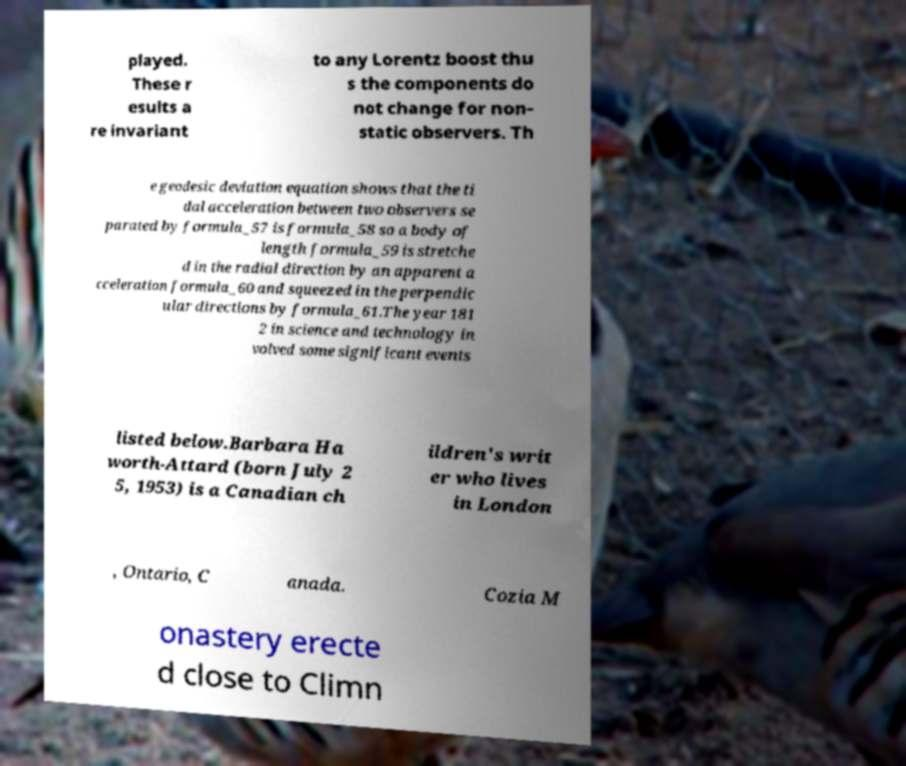Could you extract and type out the text from this image? played. These r esults a re invariant to any Lorentz boost thu s the components do not change for non- static observers. Th e geodesic deviation equation shows that the ti dal acceleration between two observers se parated by formula_57 is formula_58 so a body of length formula_59 is stretche d in the radial direction by an apparent a cceleration formula_60 and squeezed in the perpendic ular directions by formula_61.The year 181 2 in science and technology in volved some significant events listed below.Barbara Ha worth-Attard (born July 2 5, 1953) is a Canadian ch ildren's writ er who lives in London , Ontario, C anada. Cozia M onastery erecte d close to Climn 